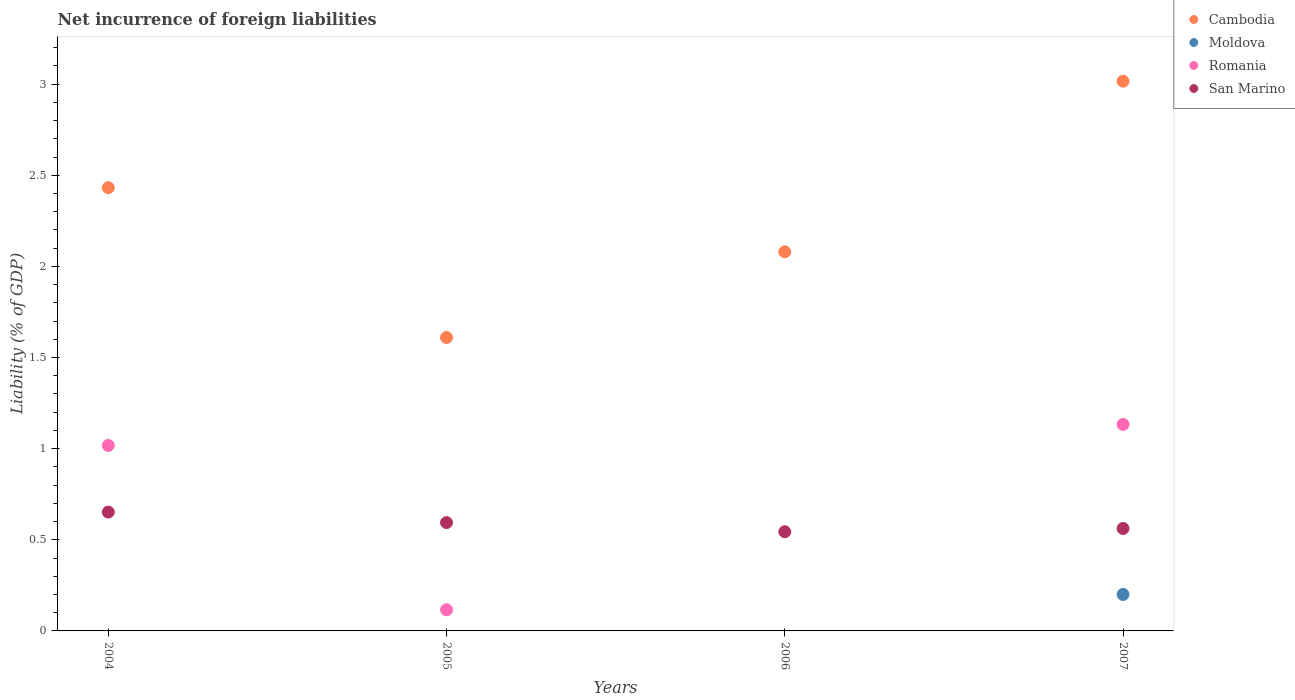How many different coloured dotlines are there?
Provide a succinct answer. 4. What is the net incurrence of foreign liabilities in Cambodia in 2005?
Give a very brief answer. 1.61. Across all years, what is the maximum net incurrence of foreign liabilities in Cambodia?
Your answer should be very brief. 3.02. Across all years, what is the minimum net incurrence of foreign liabilities in San Marino?
Ensure brevity in your answer.  0.54. In which year was the net incurrence of foreign liabilities in Cambodia maximum?
Give a very brief answer. 2007. What is the total net incurrence of foreign liabilities in Cambodia in the graph?
Your response must be concise. 9.14. What is the difference between the net incurrence of foreign liabilities in Cambodia in 2004 and that in 2006?
Give a very brief answer. 0.35. What is the difference between the net incurrence of foreign liabilities in Moldova in 2006 and the net incurrence of foreign liabilities in Cambodia in 2004?
Give a very brief answer. -2.43. What is the average net incurrence of foreign liabilities in Cambodia per year?
Offer a terse response. 2.28. In the year 2005, what is the difference between the net incurrence of foreign liabilities in Cambodia and net incurrence of foreign liabilities in San Marino?
Ensure brevity in your answer.  1.02. In how many years, is the net incurrence of foreign liabilities in San Marino greater than 2.1 %?
Your answer should be very brief. 0. What is the ratio of the net incurrence of foreign liabilities in Romania in 2004 to that in 2007?
Your answer should be very brief. 0.9. Is the difference between the net incurrence of foreign liabilities in Cambodia in 2004 and 2007 greater than the difference between the net incurrence of foreign liabilities in San Marino in 2004 and 2007?
Offer a very short reply. No. What is the difference between the highest and the second highest net incurrence of foreign liabilities in Romania?
Provide a short and direct response. 0.12. What is the difference between the highest and the lowest net incurrence of foreign liabilities in Moldova?
Offer a terse response. 0.2. Does the net incurrence of foreign liabilities in San Marino monotonically increase over the years?
Your response must be concise. No. What is the difference between two consecutive major ticks on the Y-axis?
Give a very brief answer. 0.5. Does the graph contain any zero values?
Make the answer very short. Yes. Where does the legend appear in the graph?
Your answer should be compact. Top right. What is the title of the graph?
Offer a terse response. Net incurrence of foreign liabilities. What is the label or title of the X-axis?
Offer a very short reply. Years. What is the label or title of the Y-axis?
Offer a very short reply. Liability (% of GDP). What is the Liability (% of GDP) of Cambodia in 2004?
Your answer should be very brief. 2.43. What is the Liability (% of GDP) in Romania in 2004?
Your answer should be very brief. 1.02. What is the Liability (% of GDP) of San Marino in 2004?
Provide a succinct answer. 0.65. What is the Liability (% of GDP) in Cambodia in 2005?
Your answer should be very brief. 1.61. What is the Liability (% of GDP) of Romania in 2005?
Keep it short and to the point. 0.12. What is the Liability (% of GDP) of San Marino in 2005?
Your answer should be very brief. 0.59. What is the Liability (% of GDP) of Cambodia in 2006?
Keep it short and to the point. 2.08. What is the Liability (% of GDP) of San Marino in 2006?
Your response must be concise. 0.54. What is the Liability (% of GDP) of Cambodia in 2007?
Keep it short and to the point. 3.02. What is the Liability (% of GDP) of Moldova in 2007?
Offer a very short reply. 0.2. What is the Liability (% of GDP) in Romania in 2007?
Give a very brief answer. 1.13. What is the Liability (% of GDP) of San Marino in 2007?
Keep it short and to the point. 0.56. Across all years, what is the maximum Liability (% of GDP) in Cambodia?
Ensure brevity in your answer.  3.02. Across all years, what is the maximum Liability (% of GDP) of Moldova?
Offer a terse response. 0.2. Across all years, what is the maximum Liability (% of GDP) in Romania?
Provide a short and direct response. 1.13. Across all years, what is the maximum Liability (% of GDP) of San Marino?
Give a very brief answer. 0.65. Across all years, what is the minimum Liability (% of GDP) of Cambodia?
Offer a very short reply. 1.61. Across all years, what is the minimum Liability (% of GDP) of Moldova?
Ensure brevity in your answer.  0. Across all years, what is the minimum Liability (% of GDP) in Romania?
Provide a short and direct response. 0. Across all years, what is the minimum Liability (% of GDP) of San Marino?
Give a very brief answer. 0.54. What is the total Liability (% of GDP) in Cambodia in the graph?
Provide a succinct answer. 9.14. What is the total Liability (% of GDP) in Moldova in the graph?
Your response must be concise. 0.2. What is the total Liability (% of GDP) of Romania in the graph?
Give a very brief answer. 2.27. What is the total Liability (% of GDP) in San Marino in the graph?
Keep it short and to the point. 2.35. What is the difference between the Liability (% of GDP) in Cambodia in 2004 and that in 2005?
Give a very brief answer. 0.82. What is the difference between the Liability (% of GDP) in Romania in 2004 and that in 2005?
Provide a short and direct response. 0.9. What is the difference between the Liability (% of GDP) in San Marino in 2004 and that in 2005?
Make the answer very short. 0.06. What is the difference between the Liability (% of GDP) of Cambodia in 2004 and that in 2006?
Offer a very short reply. 0.35. What is the difference between the Liability (% of GDP) in San Marino in 2004 and that in 2006?
Your answer should be very brief. 0.11. What is the difference between the Liability (% of GDP) of Cambodia in 2004 and that in 2007?
Offer a very short reply. -0.58. What is the difference between the Liability (% of GDP) of Romania in 2004 and that in 2007?
Give a very brief answer. -0.12. What is the difference between the Liability (% of GDP) in San Marino in 2004 and that in 2007?
Provide a succinct answer. 0.09. What is the difference between the Liability (% of GDP) in Cambodia in 2005 and that in 2006?
Keep it short and to the point. -0.47. What is the difference between the Liability (% of GDP) in San Marino in 2005 and that in 2006?
Give a very brief answer. 0.05. What is the difference between the Liability (% of GDP) in Cambodia in 2005 and that in 2007?
Provide a short and direct response. -1.41. What is the difference between the Liability (% of GDP) of Romania in 2005 and that in 2007?
Offer a very short reply. -1.02. What is the difference between the Liability (% of GDP) in San Marino in 2005 and that in 2007?
Offer a very short reply. 0.03. What is the difference between the Liability (% of GDP) in Cambodia in 2006 and that in 2007?
Provide a succinct answer. -0.94. What is the difference between the Liability (% of GDP) in San Marino in 2006 and that in 2007?
Your answer should be very brief. -0.02. What is the difference between the Liability (% of GDP) in Cambodia in 2004 and the Liability (% of GDP) in Romania in 2005?
Provide a succinct answer. 2.32. What is the difference between the Liability (% of GDP) of Cambodia in 2004 and the Liability (% of GDP) of San Marino in 2005?
Provide a succinct answer. 1.84. What is the difference between the Liability (% of GDP) of Romania in 2004 and the Liability (% of GDP) of San Marino in 2005?
Ensure brevity in your answer.  0.42. What is the difference between the Liability (% of GDP) in Cambodia in 2004 and the Liability (% of GDP) in San Marino in 2006?
Keep it short and to the point. 1.89. What is the difference between the Liability (% of GDP) in Romania in 2004 and the Liability (% of GDP) in San Marino in 2006?
Provide a short and direct response. 0.47. What is the difference between the Liability (% of GDP) in Cambodia in 2004 and the Liability (% of GDP) in Moldova in 2007?
Your response must be concise. 2.23. What is the difference between the Liability (% of GDP) of Cambodia in 2004 and the Liability (% of GDP) of Romania in 2007?
Offer a very short reply. 1.3. What is the difference between the Liability (% of GDP) of Cambodia in 2004 and the Liability (% of GDP) of San Marino in 2007?
Offer a very short reply. 1.87. What is the difference between the Liability (% of GDP) in Romania in 2004 and the Liability (% of GDP) in San Marino in 2007?
Your response must be concise. 0.46. What is the difference between the Liability (% of GDP) of Cambodia in 2005 and the Liability (% of GDP) of San Marino in 2006?
Your answer should be compact. 1.07. What is the difference between the Liability (% of GDP) of Romania in 2005 and the Liability (% of GDP) of San Marino in 2006?
Your response must be concise. -0.43. What is the difference between the Liability (% of GDP) in Cambodia in 2005 and the Liability (% of GDP) in Moldova in 2007?
Your response must be concise. 1.41. What is the difference between the Liability (% of GDP) in Cambodia in 2005 and the Liability (% of GDP) in Romania in 2007?
Provide a succinct answer. 0.48. What is the difference between the Liability (% of GDP) of Cambodia in 2005 and the Liability (% of GDP) of San Marino in 2007?
Offer a very short reply. 1.05. What is the difference between the Liability (% of GDP) of Romania in 2005 and the Liability (% of GDP) of San Marino in 2007?
Your response must be concise. -0.45. What is the difference between the Liability (% of GDP) of Cambodia in 2006 and the Liability (% of GDP) of Moldova in 2007?
Keep it short and to the point. 1.88. What is the difference between the Liability (% of GDP) of Cambodia in 2006 and the Liability (% of GDP) of Romania in 2007?
Offer a terse response. 0.95. What is the difference between the Liability (% of GDP) in Cambodia in 2006 and the Liability (% of GDP) in San Marino in 2007?
Your response must be concise. 1.52. What is the average Liability (% of GDP) in Cambodia per year?
Provide a succinct answer. 2.28. What is the average Liability (% of GDP) in Romania per year?
Offer a terse response. 0.57. What is the average Liability (% of GDP) in San Marino per year?
Offer a terse response. 0.59. In the year 2004, what is the difference between the Liability (% of GDP) in Cambodia and Liability (% of GDP) in Romania?
Keep it short and to the point. 1.41. In the year 2004, what is the difference between the Liability (% of GDP) in Cambodia and Liability (% of GDP) in San Marino?
Your answer should be compact. 1.78. In the year 2004, what is the difference between the Liability (% of GDP) of Romania and Liability (% of GDP) of San Marino?
Offer a terse response. 0.37. In the year 2005, what is the difference between the Liability (% of GDP) of Cambodia and Liability (% of GDP) of Romania?
Make the answer very short. 1.49. In the year 2005, what is the difference between the Liability (% of GDP) of Cambodia and Liability (% of GDP) of San Marino?
Offer a terse response. 1.02. In the year 2005, what is the difference between the Liability (% of GDP) in Romania and Liability (% of GDP) in San Marino?
Provide a succinct answer. -0.48. In the year 2006, what is the difference between the Liability (% of GDP) of Cambodia and Liability (% of GDP) of San Marino?
Your response must be concise. 1.54. In the year 2007, what is the difference between the Liability (% of GDP) of Cambodia and Liability (% of GDP) of Moldova?
Ensure brevity in your answer.  2.82. In the year 2007, what is the difference between the Liability (% of GDP) in Cambodia and Liability (% of GDP) in Romania?
Offer a very short reply. 1.88. In the year 2007, what is the difference between the Liability (% of GDP) in Cambodia and Liability (% of GDP) in San Marino?
Offer a very short reply. 2.45. In the year 2007, what is the difference between the Liability (% of GDP) in Moldova and Liability (% of GDP) in Romania?
Keep it short and to the point. -0.93. In the year 2007, what is the difference between the Liability (% of GDP) of Moldova and Liability (% of GDP) of San Marino?
Give a very brief answer. -0.36. In the year 2007, what is the difference between the Liability (% of GDP) of Romania and Liability (% of GDP) of San Marino?
Provide a succinct answer. 0.57. What is the ratio of the Liability (% of GDP) in Cambodia in 2004 to that in 2005?
Keep it short and to the point. 1.51. What is the ratio of the Liability (% of GDP) of Romania in 2004 to that in 2005?
Ensure brevity in your answer.  8.78. What is the ratio of the Liability (% of GDP) in San Marino in 2004 to that in 2005?
Give a very brief answer. 1.1. What is the ratio of the Liability (% of GDP) of Cambodia in 2004 to that in 2006?
Offer a terse response. 1.17. What is the ratio of the Liability (% of GDP) of San Marino in 2004 to that in 2006?
Give a very brief answer. 1.2. What is the ratio of the Liability (% of GDP) of Cambodia in 2004 to that in 2007?
Offer a very short reply. 0.81. What is the ratio of the Liability (% of GDP) in Romania in 2004 to that in 2007?
Offer a very short reply. 0.9. What is the ratio of the Liability (% of GDP) in San Marino in 2004 to that in 2007?
Your answer should be very brief. 1.16. What is the ratio of the Liability (% of GDP) in Cambodia in 2005 to that in 2006?
Offer a terse response. 0.77. What is the ratio of the Liability (% of GDP) of San Marino in 2005 to that in 2006?
Your answer should be compact. 1.09. What is the ratio of the Liability (% of GDP) of Cambodia in 2005 to that in 2007?
Your response must be concise. 0.53. What is the ratio of the Liability (% of GDP) of Romania in 2005 to that in 2007?
Offer a very short reply. 0.1. What is the ratio of the Liability (% of GDP) in San Marino in 2005 to that in 2007?
Offer a very short reply. 1.06. What is the ratio of the Liability (% of GDP) of Cambodia in 2006 to that in 2007?
Give a very brief answer. 0.69. What is the ratio of the Liability (% of GDP) in San Marino in 2006 to that in 2007?
Ensure brevity in your answer.  0.97. What is the difference between the highest and the second highest Liability (% of GDP) in Cambodia?
Provide a succinct answer. 0.58. What is the difference between the highest and the second highest Liability (% of GDP) of Romania?
Your answer should be compact. 0.12. What is the difference between the highest and the second highest Liability (% of GDP) of San Marino?
Ensure brevity in your answer.  0.06. What is the difference between the highest and the lowest Liability (% of GDP) in Cambodia?
Give a very brief answer. 1.41. What is the difference between the highest and the lowest Liability (% of GDP) in Moldova?
Give a very brief answer. 0.2. What is the difference between the highest and the lowest Liability (% of GDP) in Romania?
Offer a terse response. 1.13. What is the difference between the highest and the lowest Liability (% of GDP) in San Marino?
Provide a succinct answer. 0.11. 